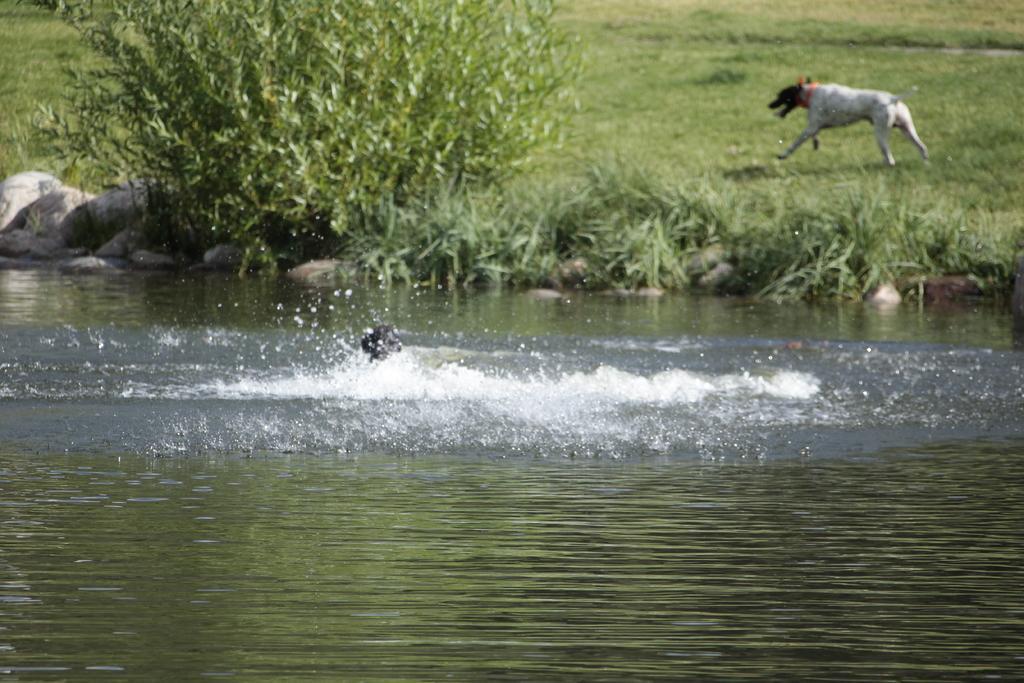Please provide a concise description of this image. In the foreground of this image, there is water and a dog in it. In the background, there is a plant, stones, grass and a dog running on the grass. 